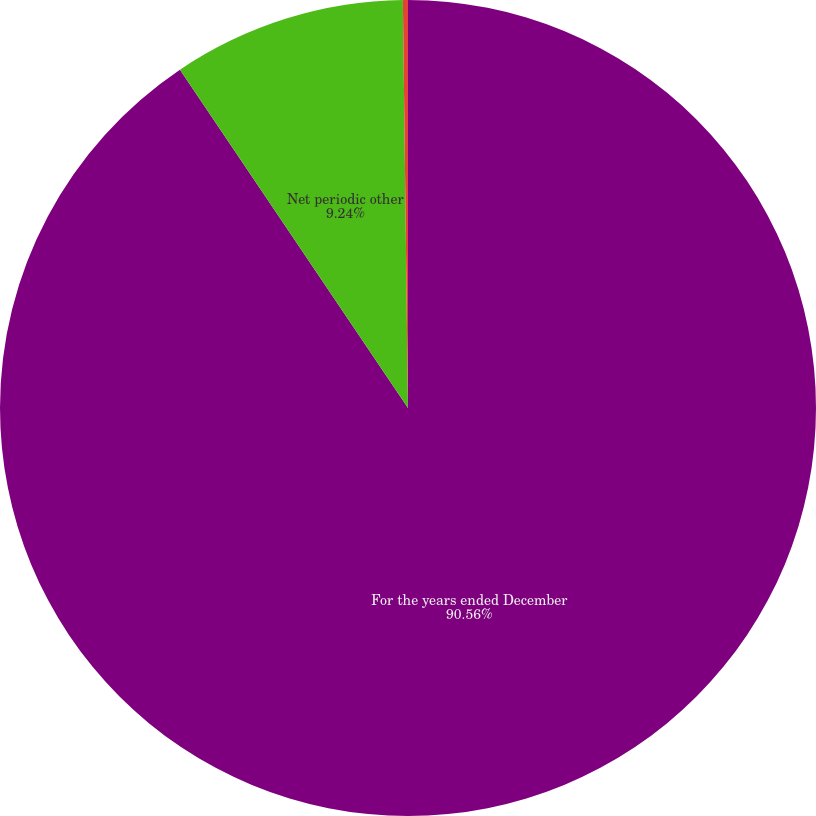<chart> <loc_0><loc_0><loc_500><loc_500><pie_chart><fcel>For the years ended December<fcel>Net periodic other<fcel>Average discount rate<nl><fcel>90.56%<fcel>9.24%<fcel>0.2%<nl></chart> 